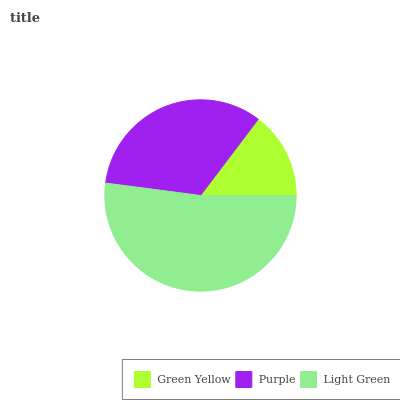Is Green Yellow the minimum?
Answer yes or no. Yes. Is Light Green the maximum?
Answer yes or no. Yes. Is Purple the minimum?
Answer yes or no. No. Is Purple the maximum?
Answer yes or no. No. Is Purple greater than Green Yellow?
Answer yes or no. Yes. Is Green Yellow less than Purple?
Answer yes or no. Yes. Is Green Yellow greater than Purple?
Answer yes or no. No. Is Purple less than Green Yellow?
Answer yes or no. No. Is Purple the high median?
Answer yes or no. Yes. Is Purple the low median?
Answer yes or no. Yes. Is Green Yellow the high median?
Answer yes or no. No. Is Green Yellow the low median?
Answer yes or no. No. 